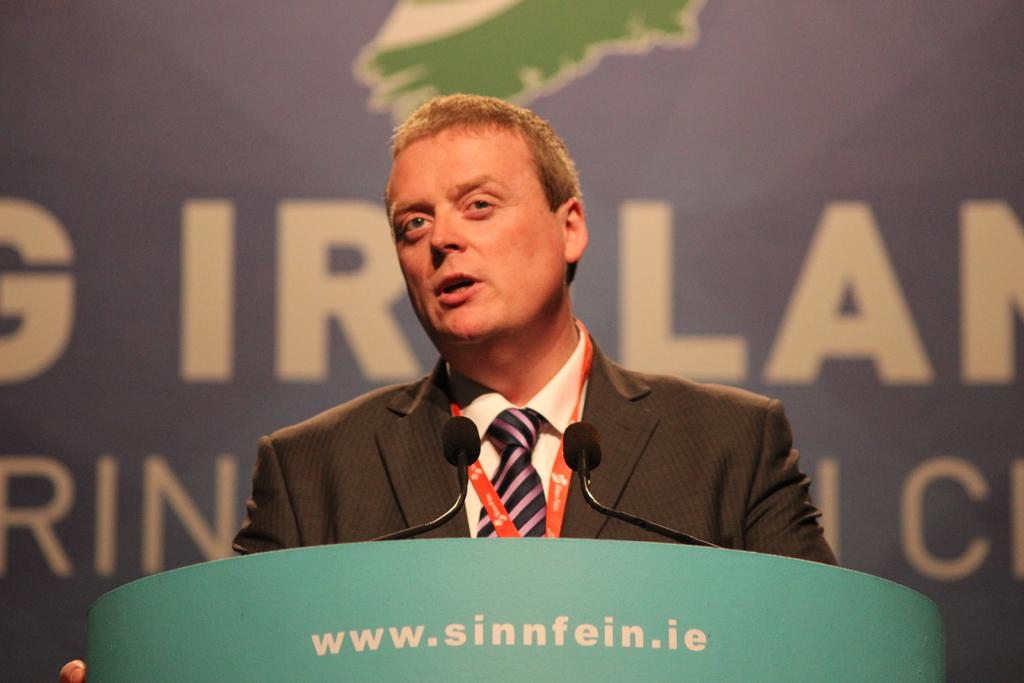Who is present in the image? There is a man in the image. What is the man wearing? The man is wearing a blazer. What is the man doing in the image? The man is standing behind a podium. What can be seen on the podium? There are microphones on the podium. What is visible in the background of the image? There is a board visible in the background. What type of corn is being served on the podium in the image? There is no corn present in the image; the podium has microphones on it. 